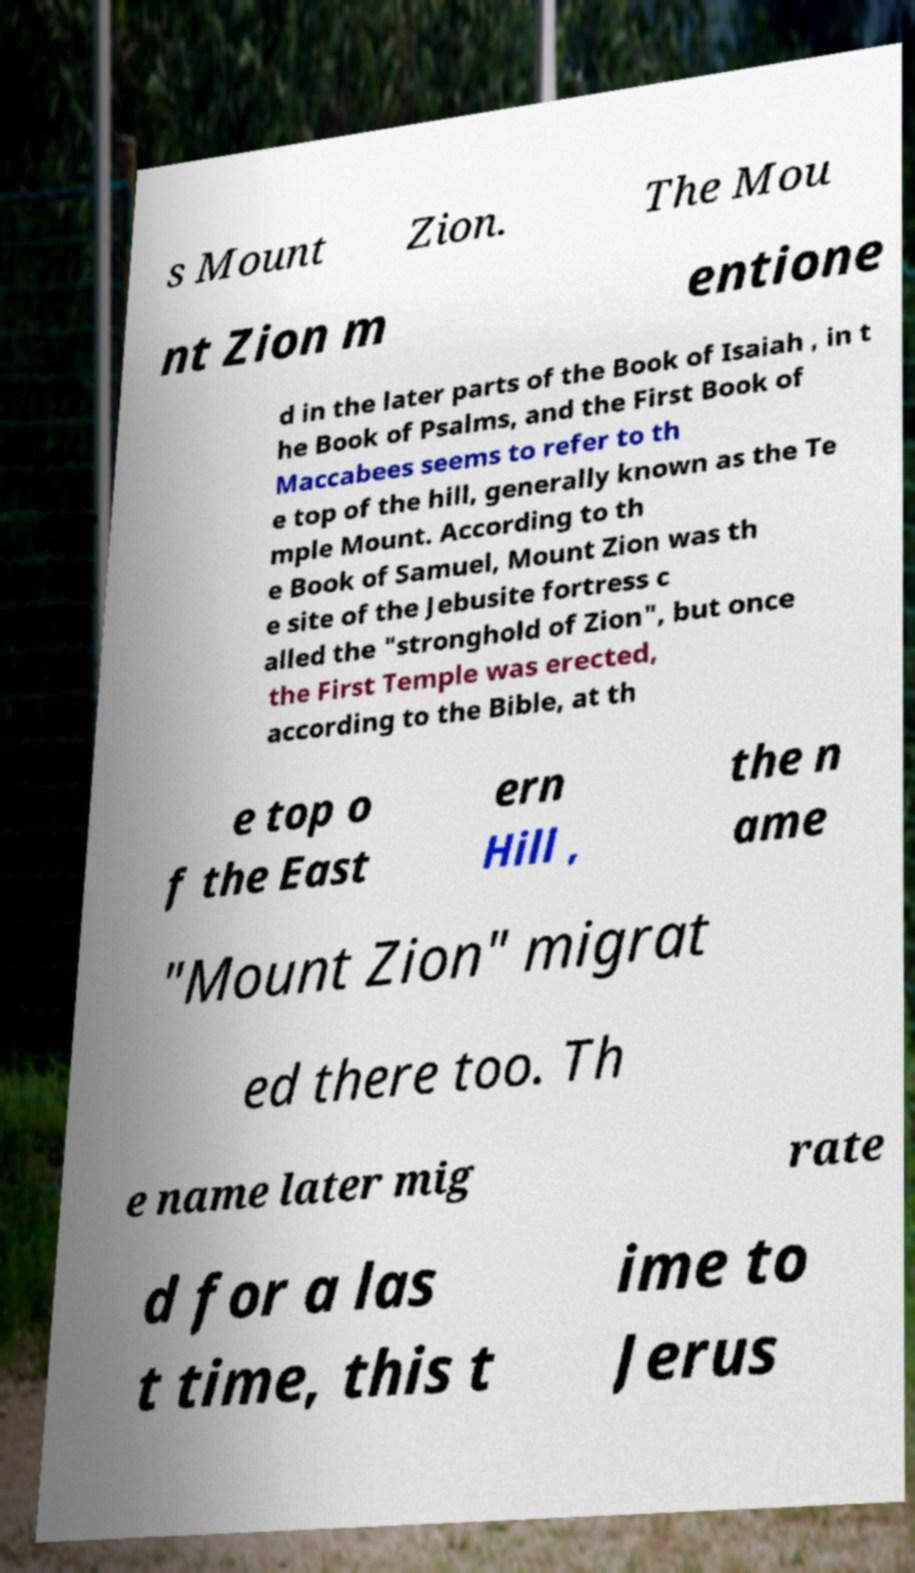I need the written content from this picture converted into text. Can you do that? s Mount Zion. The Mou nt Zion m entione d in the later parts of the Book of Isaiah , in t he Book of Psalms, and the First Book of Maccabees seems to refer to th e top of the hill, generally known as the Te mple Mount. According to th e Book of Samuel, Mount Zion was th e site of the Jebusite fortress c alled the "stronghold of Zion", but once the First Temple was erected, according to the Bible, at th e top o f the East ern Hill , the n ame "Mount Zion" migrat ed there too. Th e name later mig rate d for a las t time, this t ime to Jerus 